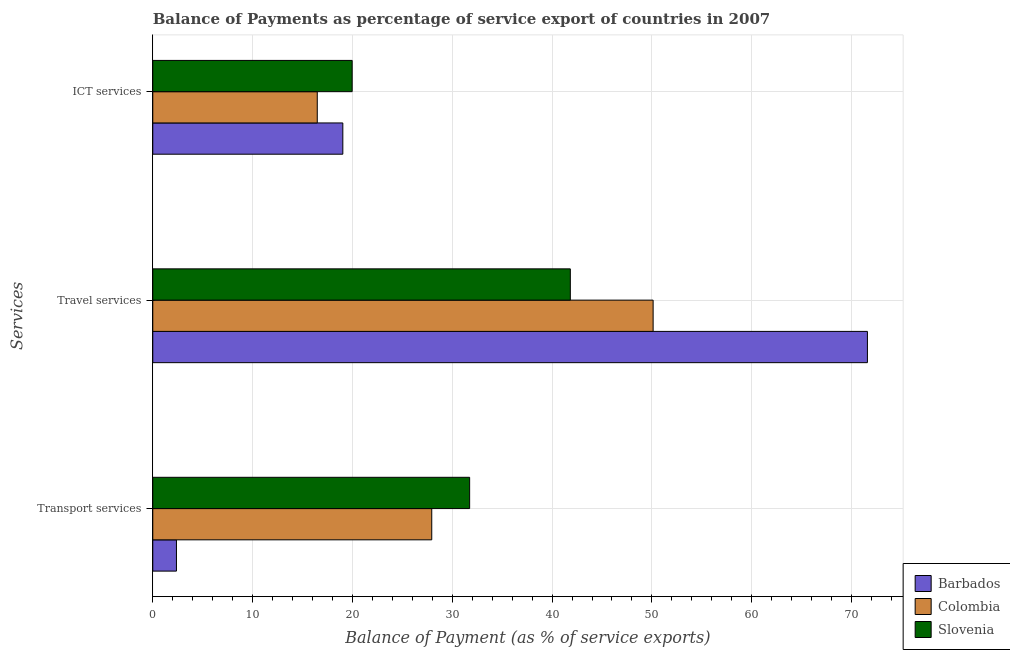How many different coloured bars are there?
Ensure brevity in your answer.  3. Are the number of bars per tick equal to the number of legend labels?
Keep it short and to the point. Yes. How many bars are there on the 2nd tick from the top?
Your answer should be compact. 3. How many bars are there on the 2nd tick from the bottom?
Provide a short and direct response. 3. What is the label of the 1st group of bars from the top?
Make the answer very short. ICT services. What is the balance of payment of transport services in Barbados?
Give a very brief answer. 2.37. Across all countries, what is the maximum balance of payment of travel services?
Your response must be concise. 71.59. Across all countries, what is the minimum balance of payment of transport services?
Make the answer very short. 2.37. In which country was the balance of payment of travel services maximum?
Give a very brief answer. Barbados. What is the total balance of payment of ict services in the graph?
Keep it short and to the point. 55.49. What is the difference between the balance of payment of ict services in Colombia and that in Slovenia?
Give a very brief answer. -3.5. What is the difference between the balance of payment of transport services in Barbados and the balance of payment of travel services in Colombia?
Your answer should be very brief. -47.75. What is the average balance of payment of travel services per country?
Make the answer very short. 54.51. What is the difference between the balance of payment of ict services and balance of payment of transport services in Slovenia?
Your response must be concise. -11.77. In how many countries, is the balance of payment of travel services greater than 34 %?
Provide a short and direct response. 3. What is the ratio of the balance of payment of travel services in Barbados to that in Slovenia?
Your response must be concise. 1.71. Is the balance of payment of ict services in Barbados less than that in Colombia?
Offer a terse response. No. Is the difference between the balance of payment of ict services in Slovenia and Barbados greater than the difference between the balance of payment of travel services in Slovenia and Barbados?
Make the answer very short. Yes. What is the difference between the highest and the second highest balance of payment of ict services?
Offer a very short reply. 0.93. What is the difference between the highest and the lowest balance of payment of transport services?
Provide a succinct answer. 29.37. In how many countries, is the balance of payment of ict services greater than the average balance of payment of ict services taken over all countries?
Your response must be concise. 2. Is the sum of the balance of payment of transport services in Slovenia and Colombia greater than the maximum balance of payment of ict services across all countries?
Keep it short and to the point. Yes. What does the 1st bar from the top in Travel services represents?
Your answer should be very brief. Slovenia. What does the 2nd bar from the bottom in Transport services represents?
Offer a very short reply. Colombia. Is it the case that in every country, the sum of the balance of payment of transport services and balance of payment of travel services is greater than the balance of payment of ict services?
Provide a succinct answer. Yes. What is the difference between two consecutive major ticks on the X-axis?
Your answer should be compact. 10. Are the values on the major ticks of X-axis written in scientific E-notation?
Offer a very short reply. No. Does the graph contain any zero values?
Offer a very short reply. No. What is the title of the graph?
Your response must be concise. Balance of Payments as percentage of service export of countries in 2007. What is the label or title of the X-axis?
Your answer should be compact. Balance of Payment (as % of service exports). What is the label or title of the Y-axis?
Provide a succinct answer. Services. What is the Balance of Payment (as % of service exports) of Barbados in Transport services?
Offer a terse response. 2.37. What is the Balance of Payment (as % of service exports) in Colombia in Transport services?
Keep it short and to the point. 27.95. What is the Balance of Payment (as % of service exports) of Slovenia in Transport services?
Provide a succinct answer. 31.74. What is the Balance of Payment (as % of service exports) of Barbados in Travel services?
Keep it short and to the point. 71.59. What is the Balance of Payment (as % of service exports) of Colombia in Travel services?
Offer a very short reply. 50.12. What is the Balance of Payment (as % of service exports) of Slovenia in Travel services?
Give a very brief answer. 41.83. What is the Balance of Payment (as % of service exports) of Barbados in ICT services?
Keep it short and to the point. 19.04. What is the Balance of Payment (as % of service exports) of Colombia in ICT services?
Keep it short and to the point. 16.48. What is the Balance of Payment (as % of service exports) in Slovenia in ICT services?
Keep it short and to the point. 19.97. Across all Services, what is the maximum Balance of Payment (as % of service exports) in Barbados?
Your response must be concise. 71.59. Across all Services, what is the maximum Balance of Payment (as % of service exports) in Colombia?
Ensure brevity in your answer.  50.12. Across all Services, what is the maximum Balance of Payment (as % of service exports) in Slovenia?
Keep it short and to the point. 41.83. Across all Services, what is the minimum Balance of Payment (as % of service exports) of Barbados?
Offer a very short reply. 2.37. Across all Services, what is the minimum Balance of Payment (as % of service exports) in Colombia?
Give a very brief answer. 16.48. Across all Services, what is the minimum Balance of Payment (as % of service exports) in Slovenia?
Keep it short and to the point. 19.97. What is the total Balance of Payment (as % of service exports) in Barbados in the graph?
Your answer should be very brief. 93. What is the total Balance of Payment (as % of service exports) of Colombia in the graph?
Your answer should be very brief. 94.54. What is the total Balance of Payment (as % of service exports) of Slovenia in the graph?
Your answer should be compact. 93.54. What is the difference between the Balance of Payment (as % of service exports) of Barbados in Transport services and that in Travel services?
Make the answer very short. -69.21. What is the difference between the Balance of Payment (as % of service exports) of Colombia in Transport services and that in Travel services?
Offer a very short reply. -22.18. What is the difference between the Balance of Payment (as % of service exports) of Slovenia in Transport services and that in Travel services?
Make the answer very short. -10.09. What is the difference between the Balance of Payment (as % of service exports) in Barbados in Transport services and that in ICT services?
Your answer should be compact. -16.67. What is the difference between the Balance of Payment (as % of service exports) in Colombia in Transport services and that in ICT services?
Give a very brief answer. 11.47. What is the difference between the Balance of Payment (as % of service exports) of Slovenia in Transport services and that in ICT services?
Your answer should be very brief. 11.77. What is the difference between the Balance of Payment (as % of service exports) in Barbados in Travel services and that in ICT services?
Ensure brevity in your answer.  52.55. What is the difference between the Balance of Payment (as % of service exports) in Colombia in Travel services and that in ICT services?
Your response must be concise. 33.64. What is the difference between the Balance of Payment (as % of service exports) in Slovenia in Travel services and that in ICT services?
Keep it short and to the point. 21.85. What is the difference between the Balance of Payment (as % of service exports) in Barbados in Transport services and the Balance of Payment (as % of service exports) in Colombia in Travel services?
Your answer should be compact. -47.75. What is the difference between the Balance of Payment (as % of service exports) of Barbados in Transport services and the Balance of Payment (as % of service exports) of Slovenia in Travel services?
Keep it short and to the point. -39.45. What is the difference between the Balance of Payment (as % of service exports) of Colombia in Transport services and the Balance of Payment (as % of service exports) of Slovenia in Travel services?
Provide a short and direct response. -13.88. What is the difference between the Balance of Payment (as % of service exports) of Barbados in Transport services and the Balance of Payment (as % of service exports) of Colombia in ICT services?
Make the answer very short. -14.11. What is the difference between the Balance of Payment (as % of service exports) of Barbados in Transport services and the Balance of Payment (as % of service exports) of Slovenia in ICT services?
Make the answer very short. -17.6. What is the difference between the Balance of Payment (as % of service exports) of Colombia in Transport services and the Balance of Payment (as % of service exports) of Slovenia in ICT services?
Offer a very short reply. 7.97. What is the difference between the Balance of Payment (as % of service exports) of Barbados in Travel services and the Balance of Payment (as % of service exports) of Colombia in ICT services?
Keep it short and to the point. 55.11. What is the difference between the Balance of Payment (as % of service exports) in Barbados in Travel services and the Balance of Payment (as % of service exports) in Slovenia in ICT services?
Keep it short and to the point. 51.61. What is the difference between the Balance of Payment (as % of service exports) in Colombia in Travel services and the Balance of Payment (as % of service exports) in Slovenia in ICT services?
Your response must be concise. 30.15. What is the average Balance of Payment (as % of service exports) of Barbados per Services?
Provide a short and direct response. 31. What is the average Balance of Payment (as % of service exports) in Colombia per Services?
Provide a succinct answer. 31.51. What is the average Balance of Payment (as % of service exports) in Slovenia per Services?
Give a very brief answer. 31.18. What is the difference between the Balance of Payment (as % of service exports) of Barbados and Balance of Payment (as % of service exports) of Colombia in Transport services?
Your answer should be compact. -25.57. What is the difference between the Balance of Payment (as % of service exports) in Barbados and Balance of Payment (as % of service exports) in Slovenia in Transport services?
Give a very brief answer. -29.37. What is the difference between the Balance of Payment (as % of service exports) in Colombia and Balance of Payment (as % of service exports) in Slovenia in Transport services?
Your response must be concise. -3.8. What is the difference between the Balance of Payment (as % of service exports) of Barbados and Balance of Payment (as % of service exports) of Colombia in Travel services?
Offer a very short reply. 21.47. What is the difference between the Balance of Payment (as % of service exports) in Barbados and Balance of Payment (as % of service exports) in Slovenia in Travel services?
Provide a short and direct response. 29.76. What is the difference between the Balance of Payment (as % of service exports) in Colombia and Balance of Payment (as % of service exports) in Slovenia in Travel services?
Give a very brief answer. 8.29. What is the difference between the Balance of Payment (as % of service exports) of Barbados and Balance of Payment (as % of service exports) of Colombia in ICT services?
Provide a succinct answer. 2.56. What is the difference between the Balance of Payment (as % of service exports) in Barbados and Balance of Payment (as % of service exports) in Slovenia in ICT services?
Ensure brevity in your answer.  -0.93. What is the difference between the Balance of Payment (as % of service exports) in Colombia and Balance of Payment (as % of service exports) in Slovenia in ICT services?
Offer a terse response. -3.5. What is the ratio of the Balance of Payment (as % of service exports) in Barbados in Transport services to that in Travel services?
Provide a short and direct response. 0.03. What is the ratio of the Balance of Payment (as % of service exports) in Colombia in Transport services to that in Travel services?
Ensure brevity in your answer.  0.56. What is the ratio of the Balance of Payment (as % of service exports) of Slovenia in Transport services to that in Travel services?
Your answer should be compact. 0.76. What is the ratio of the Balance of Payment (as % of service exports) in Barbados in Transport services to that in ICT services?
Offer a very short reply. 0.12. What is the ratio of the Balance of Payment (as % of service exports) in Colombia in Transport services to that in ICT services?
Provide a succinct answer. 1.7. What is the ratio of the Balance of Payment (as % of service exports) of Slovenia in Transport services to that in ICT services?
Your answer should be very brief. 1.59. What is the ratio of the Balance of Payment (as % of service exports) in Barbados in Travel services to that in ICT services?
Offer a terse response. 3.76. What is the ratio of the Balance of Payment (as % of service exports) in Colombia in Travel services to that in ICT services?
Your answer should be very brief. 3.04. What is the ratio of the Balance of Payment (as % of service exports) of Slovenia in Travel services to that in ICT services?
Ensure brevity in your answer.  2.09. What is the difference between the highest and the second highest Balance of Payment (as % of service exports) of Barbados?
Your response must be concise. 52.55. What is the difference between the highest and the second highest Balance of Payment (as % of service exports) of Colombia?
Provide a short and direct response. 22.18. What is the difference between the highest and the second highest Balance of Payment (as % of service exports) in Slovenia?
Your response must be concise. 10.09. What is the difference between the highest and the lowest Balance of Payment (as % of service exports) of Barbados?
Make the answer very short. 69.21. What is the difference between the highest and the lowest Balance of Payment (as % of service exports) of Colombia?
Offer a very short reply. 33.64. What is the difference between the highest and the lowest Balance of Payment (as % of service exports) in Slovenia?
Keep it short and to the point. 21.85. 